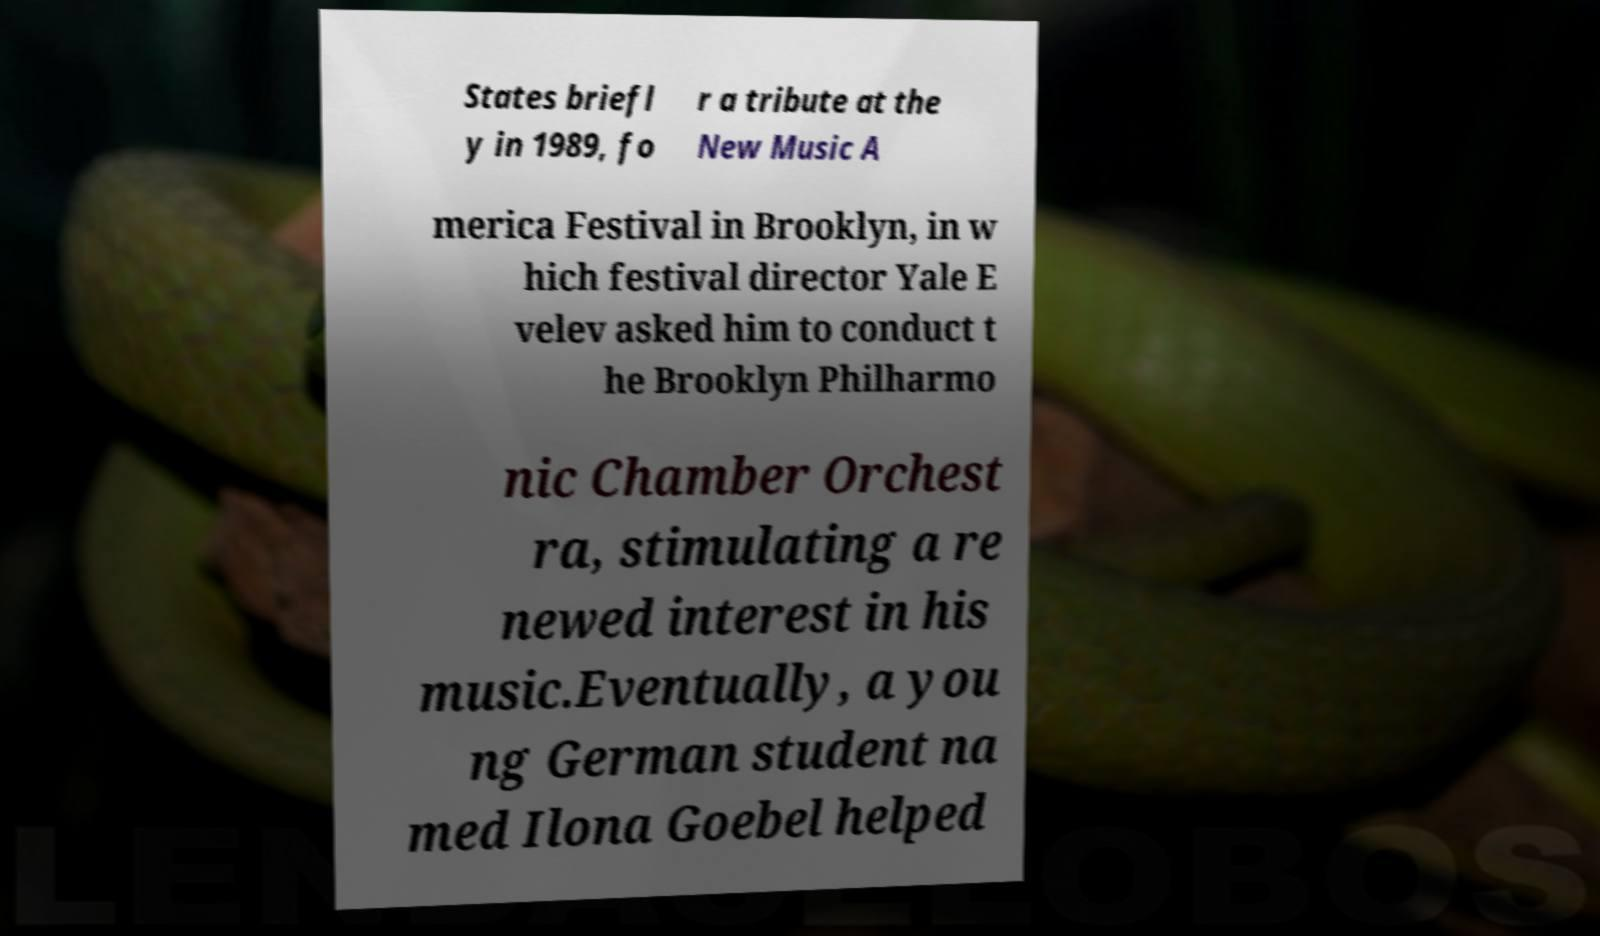I need the written content from this picture converted into text. Can you do that? States briefl y in 1989, fo r a tribute at the New Music A merica Festival in Brooklyn, in w hich festival director Yale E velev asked him to conduct t he Brooklyn Philharmo nic Chamber Orchest ra, stimulating a re newed interest in his music.Eventually, a you ng German student na med Ilona Goebel helped 